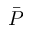Convert formula to latex. <formula><loc_0><loc_0><loc_500><loc_500>\bar { P }</formula> 